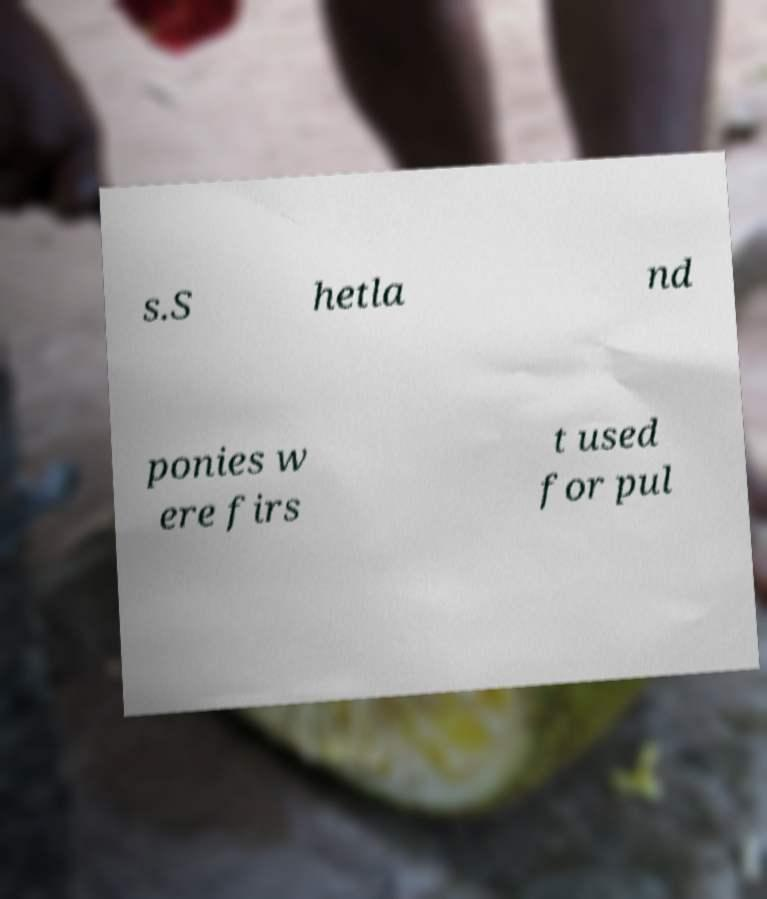Can you read and provide the text displayed in the image?This photo seems to have some interesting text. Can you extract and type it out for me? s.S hetla nd ponies w ere firs t used for pul 